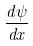Convert formula to latex. <formula><loc_0><loc_0><loc_500><loc_500>\frac { d \psi } { d x }</formula> 